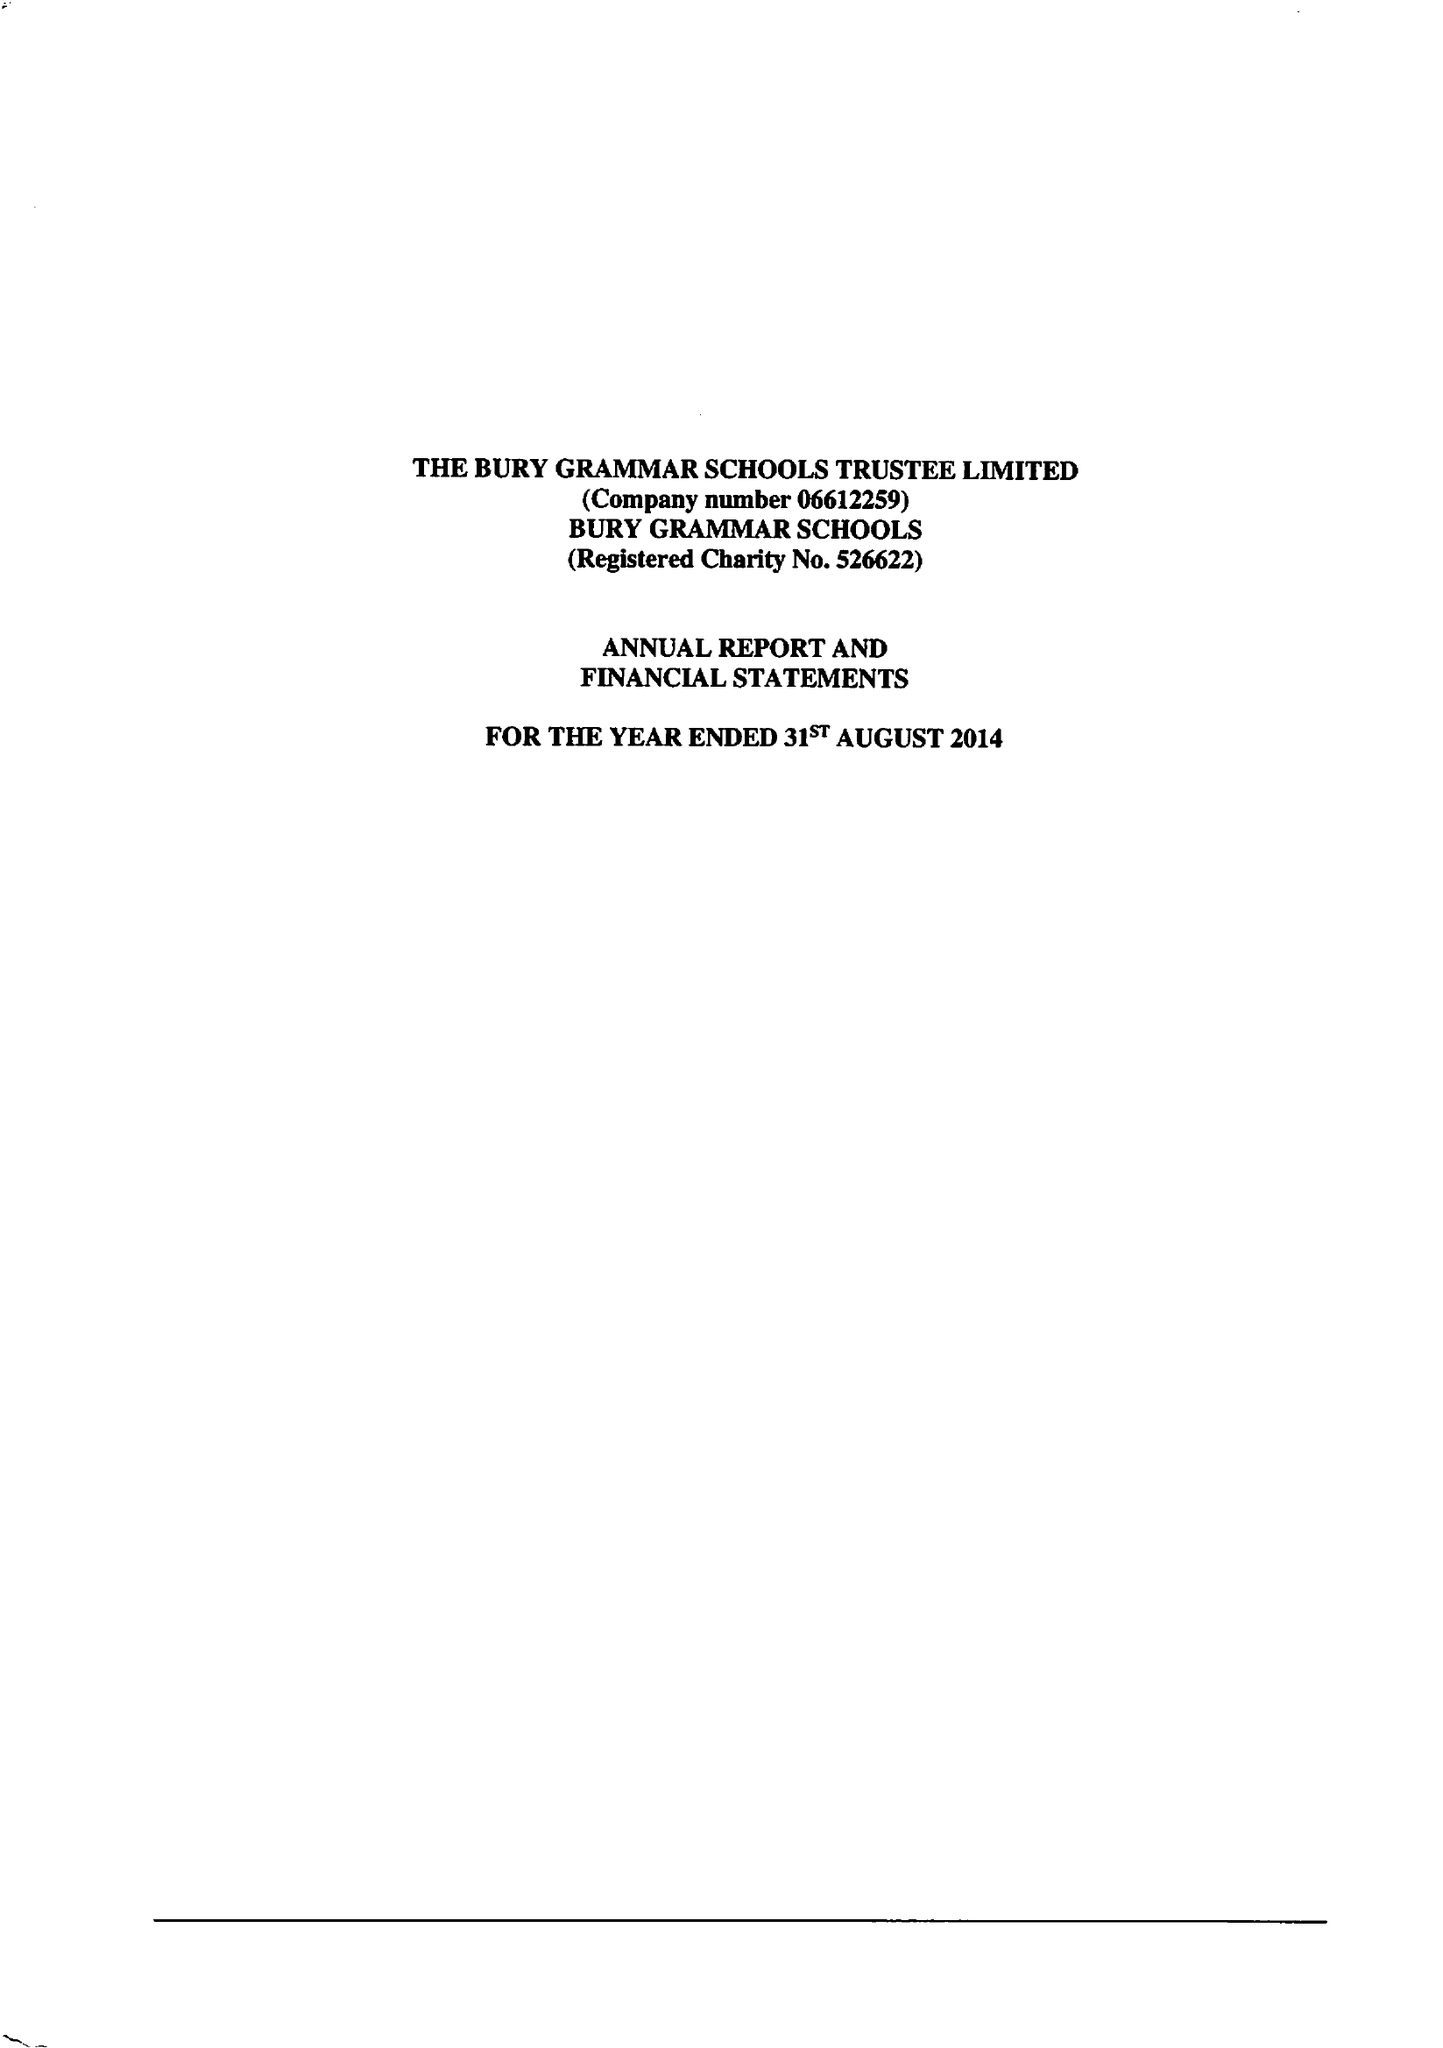What is the value for the address__street_line?
Answer the question using a single word or phrase. BRIDGE ROAD 